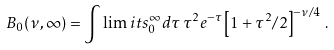Convert formula to latex. <formula><loc_0><loc_0><loc_500><loc_500>B _ { 0 } ( \nu , \infty ) = \int \lim i t s _ { 0 } ^ { \infty } d \tau \, \tau ^ { 2 } e ^ { - \tau } \left [ 1 + \tau ^ { 2 } / 2 \right ] ^ { - \nu / 4 } \, .</formula> 